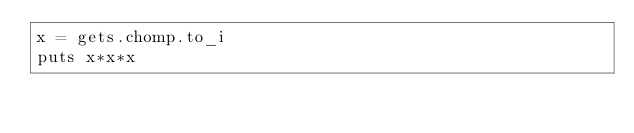<code> <loc_0><loc_0><loc_500><loc_500><_Ruby_>x = gets.chomp.to_i
puts x*x*x
</code> 